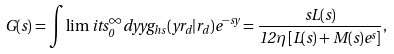Convert formula to latex. <formula><loc_0><loc_0><loc_500><loc_500>G ( s ) = \int \lim i t s _ { 0 } ^ { \infty } d y y g _ { h s } ( y r _ { d } | r _ { d } ) e ^ { - s y } = \frac { s L ( s ) } { 1 2 \eta \left [ L ( s ) + M ( s ) e ^ { s } \right ] } ,</formula> 